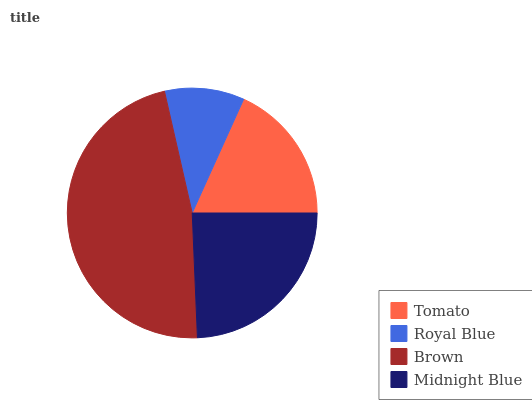Is Royal Blue the minimum?
Answer yes or no. Yes. Is Brown the maximum?
Answer yes or no. Yes. Is Brown the minimum?
Answer yes or no. No. Is Royal Blue the maximum?
Answer yes or no. No. Is Brown greater than Royal Blue?
Answer yes or no. Yes. Is Royal Blue less than Brown?
Answer yes or no. Yes. Is Royal Blue greater than Brown?
Answer yes or no. No. Is Brown less than Royal Blue?
Answer yes or no. No. Is Midnight Blue the high median?
Answer yes or no. Yes. Is Tomato the low median?
Answer yes or no. Yes. Is Tomato the high median?
Answer yes or no. No. Is Royal Blue the low median?
Answer yes or no. No. 